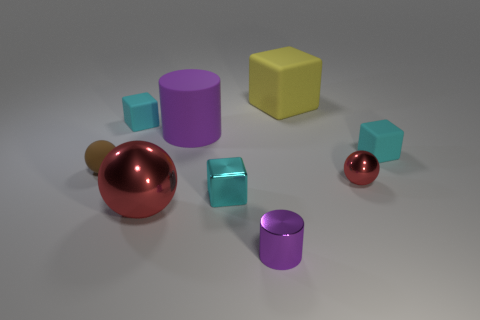There is another cylinder that is the same color as the small cylinder; what material is it?
Your response must be concise. Rubber. Are there more tiny shiny objects that are left of the purple metallic cylinder than tiny shiny blocks that are behind the large purple cylinder?
Make the answer very short. Yes. What material is the big object that is the same shape as the small red object?
Keep it short and to the point. Metal. Are there any other things that have the same size as the yellow thing?
Provide a succinct answer. Yes. There is a tiny sphere on the right side of the small brown ball; is its color the same as the cylinder in front of the small brown object?
Offer a terse response. No. The yellow matte thing has what shape?
Make the answer very short. Cube. Is the number of big red metal balls behind the small cyan metal object greater than the number of brown matte spheres?
Give a very brief answer. No. What is the shape of the cyan metallic thing left of the tiny purple shiny thing?
Make the answer very short. Cube. What number of other objects are the same shape as the yellow rubber object?
Make the answer very short. 3. Do the red sphere right of the tiny cylinder and the big yellow object have the same material?
Provide a succinct answer. No. 